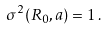<formula> <loc_0><loc_0><loc_500><loc_500>\sigma ^ { 2 } ( R _ { 0 } , a ) = 1 \, .</formula> 